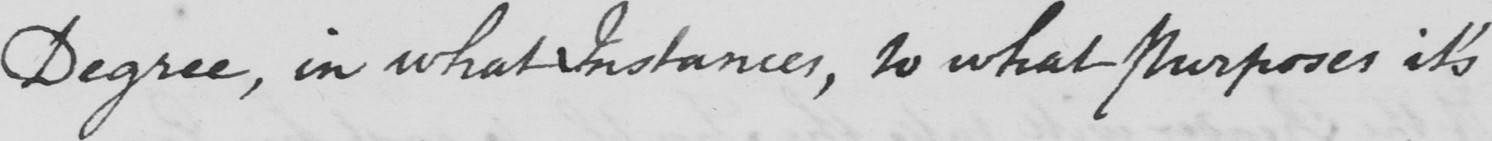Can you read and transcribe this handwriting? Degree , in what Instances , to what Purposes it ' s 